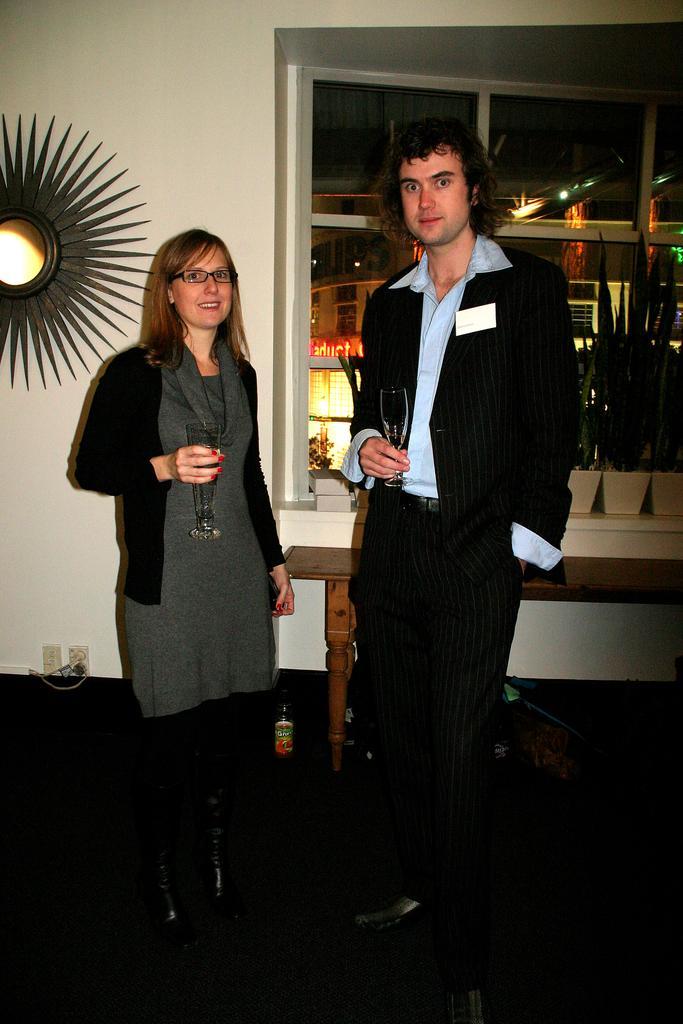Can you describe this image briefly? In this picture I can see a man and woman standing holding glasses in their hands and I can see showpiece on the wall and I can see a bottle on the floor and I can see a glass window and few plants in the pots and from the glass I can see buildings. 